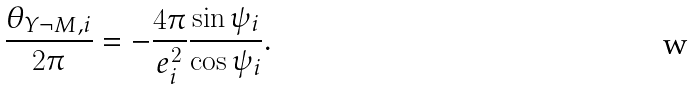<formula> <loc_0><loc_0><loc_500><loc_500>\frac { \theta _ { Y \neg M , i } } { 2 \pi } = - \frac { 4 \pi } { e _ { i } ^ { 2 } } \frac { \sin \psi _ { i } } { \cos \psi _ { i } } .</formula> 